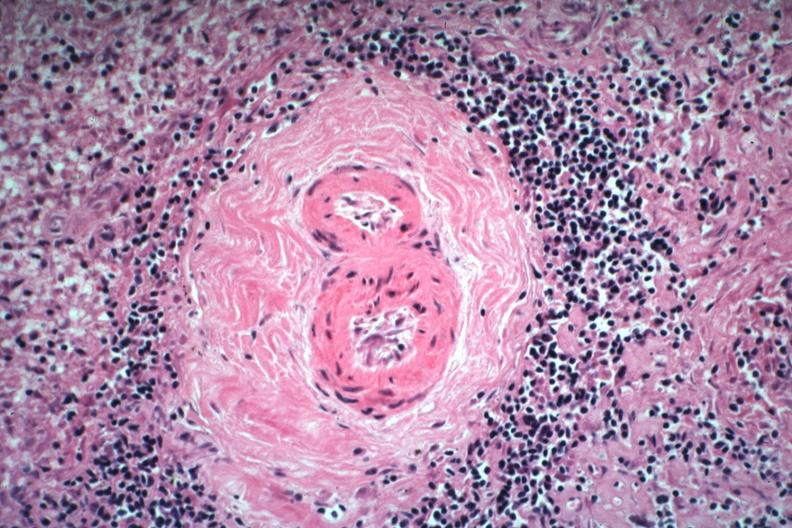what is present?
Answer the question using a single word or phrase. Hematologic 